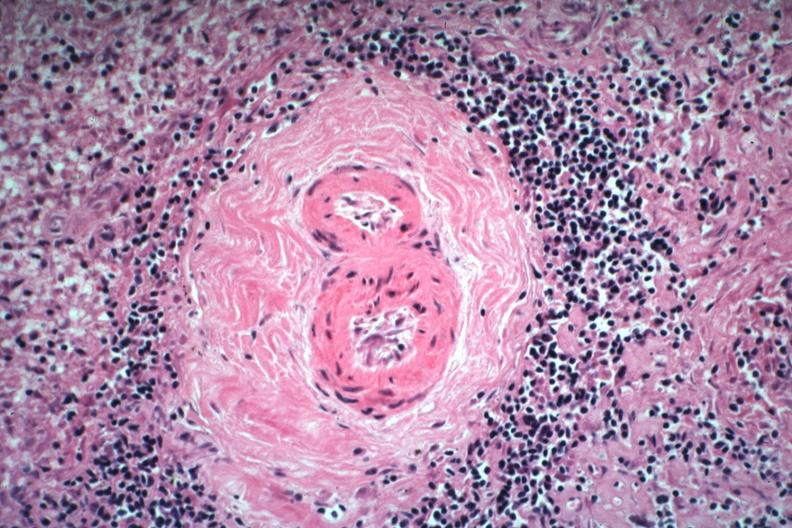what is present?
Answer the question using a single word or phrase. Hematologic 